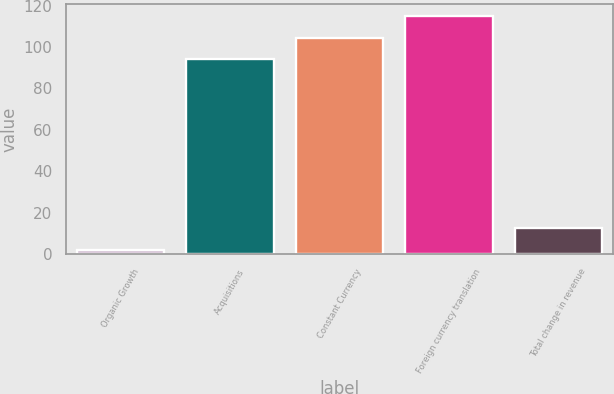Convert chart to OTSL. <chart><loc_0><loc_0><loc_500><loc_500><bar_chart><fcel>Organic Growth<fcel>Acquisitions<fcel>Constant Currency<fcel>Foreign currency translation<fcel>Total change in revenue<nl><fcel>2<fcel>94<fcel>104.6<fcel>115.2<fcel>12.6<nl></chart> 